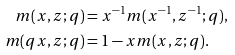<formula> <loc_0><loc_0><loc_500><loc_500>m ( x , z ; q ) & = x ^ { - 1 } m ( x ^ { - 1 } , z ^ { - 1 } ; q ) , \\ m ( q x , z ; q ) & = 1 - x m ( x , z ; q ) .</formula> 